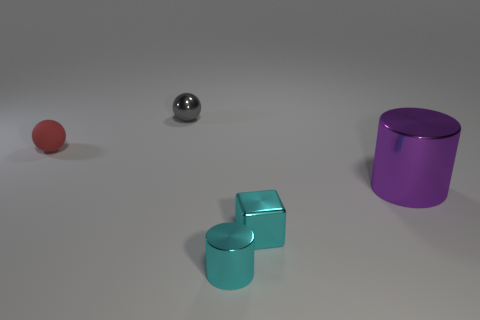The metallic cylinder that is the same color as the small cube is what size? The metallic cylinder, sharing the same purple hue as the small cube situated to its right, is of a small size, consistent with the size of the cube. 